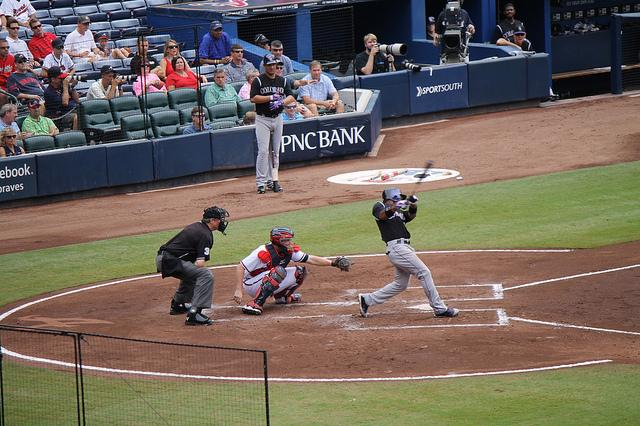Who is an all-time legend for one of these teams? todd helton 